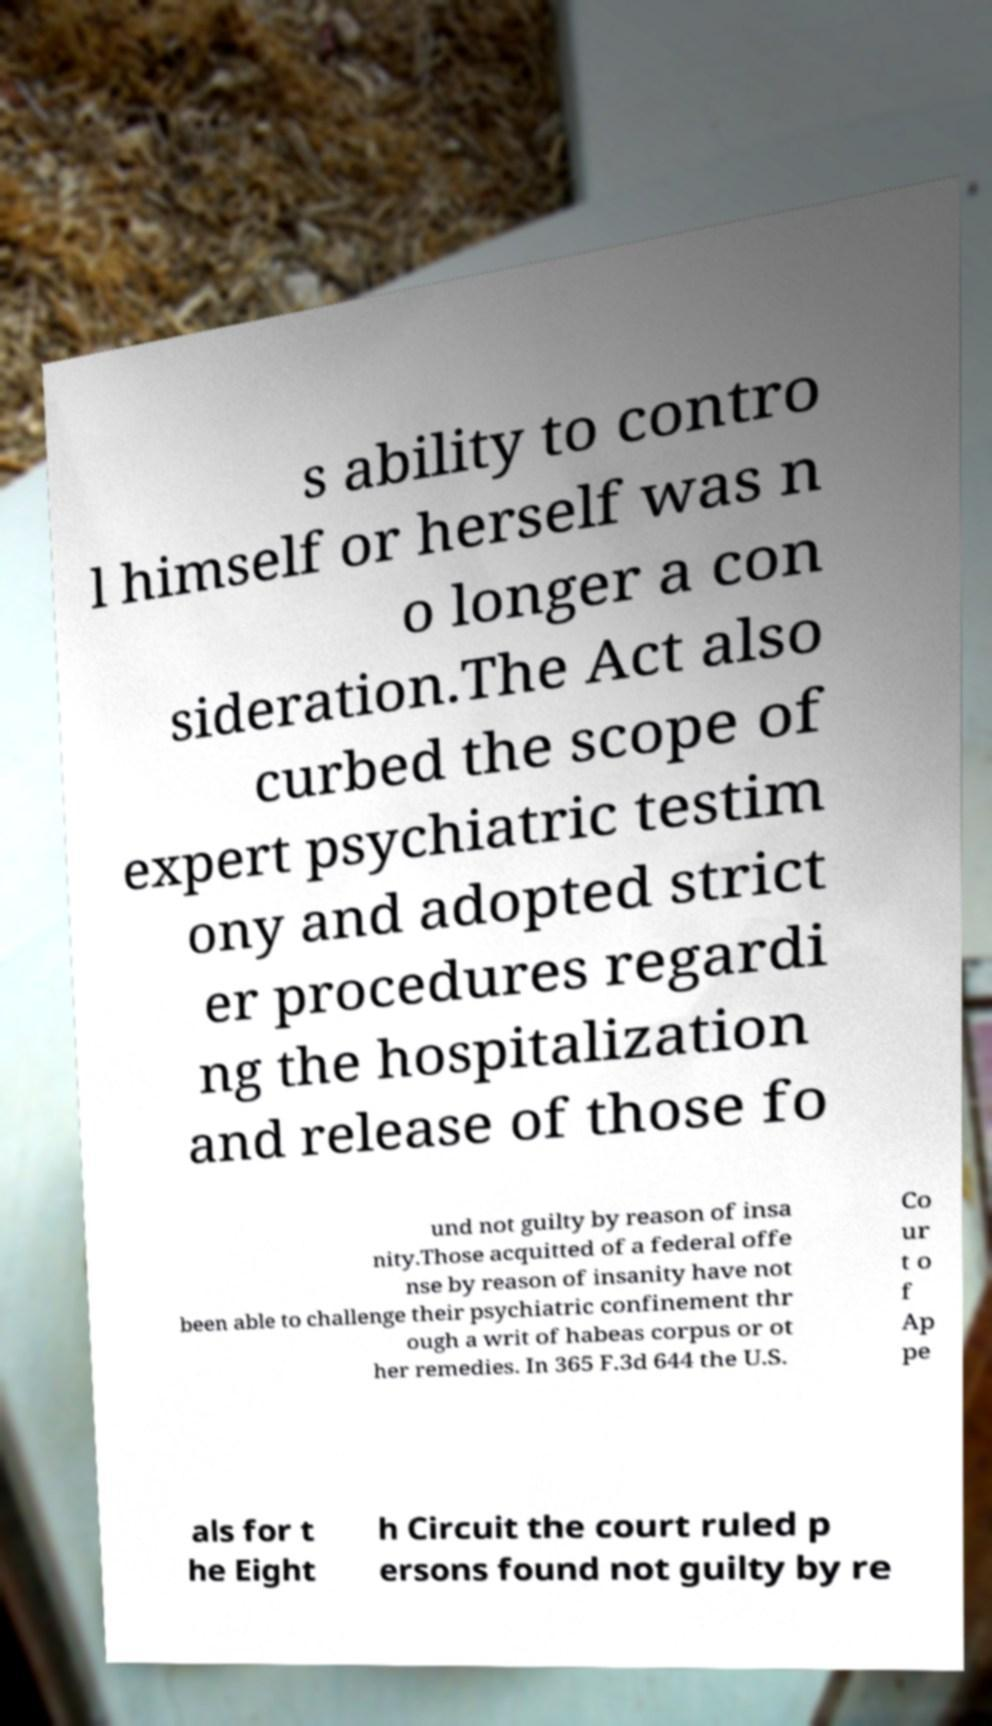Please read and relay the text visible in this image. What does it say? s ability to contro l himself or herself was n o longer a con sideration.The Act also curbed the scope of expert psychiatric testim ony and adopted strict er procedures regardi ng the hospitalization and release of those fo und not guilty by reason of insa nity.Those acquitted of a federal offe nse by reason of insanity have not been able to challenge their psychiatric confinement thr ough a writ of habeas corpus or ot her remedies. In 365 F.3d 644 the U.S. Co ur t o f Ap pe als for t he Eight h Circuit the court ruled p ersons found not guilty by re 